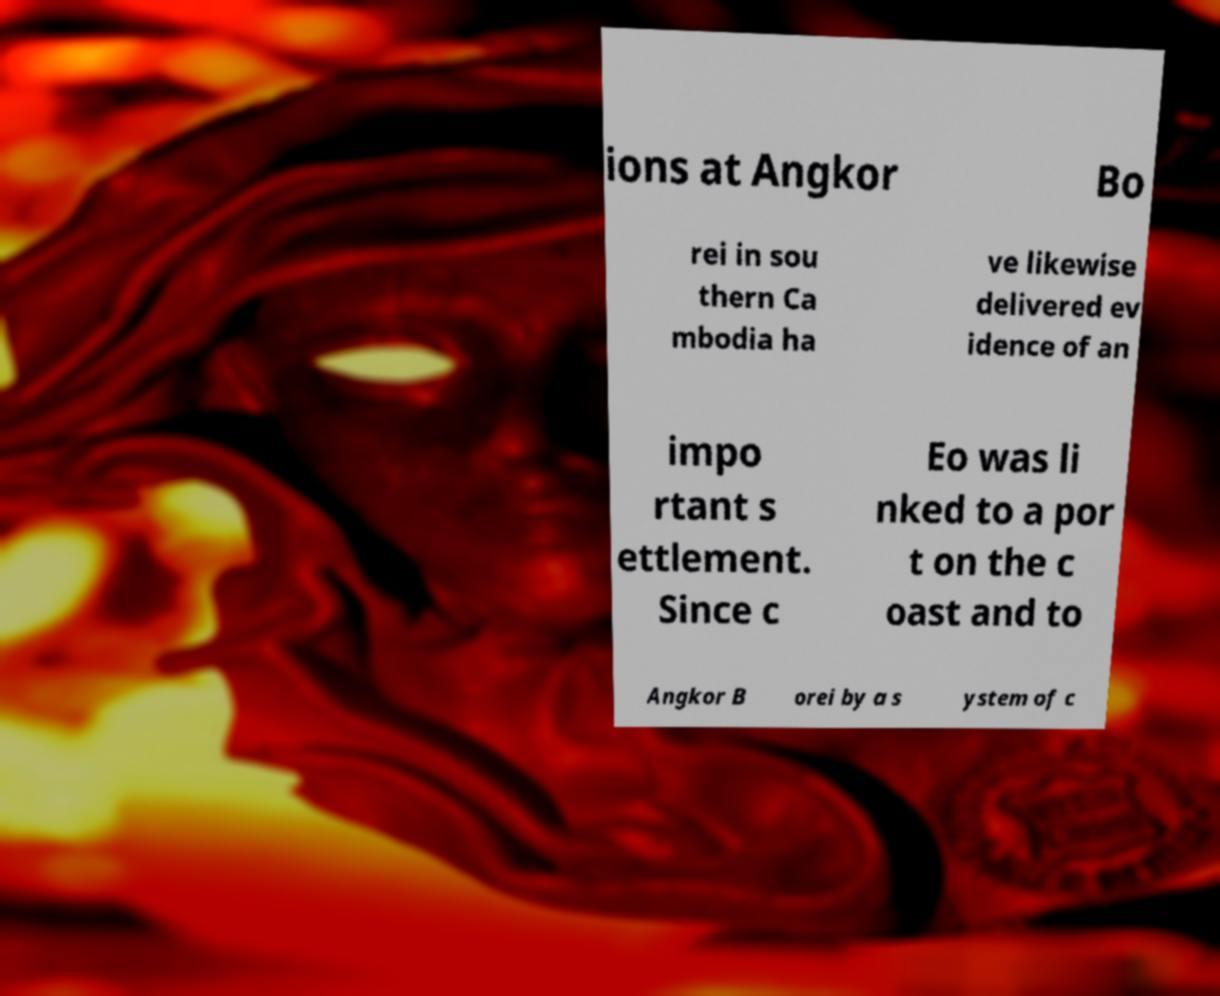For documentation purposes, I need the text within this image transcribed. Could you provide that? ions at Angkor Bo rei in sou thern Ca mbodia ha ve likewise delivered ev idence of an impo rtant s ettlement. Since c Eo was li nked to a por t on the c oast and to Angkor B orei by a s ystem of c 